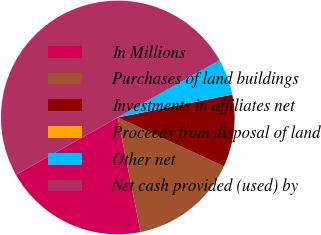Convert chart. <chart><loc_0><loc_0><loc_500><loc_500><pie_chart><fcel>In Millions<fcel>Purchases of land buildings<fcel>Investments in affiliates net<fcel>Proceeds from disposal of land<fcel>Other net<fcel>Net cash provided (used) by<nl><fcel>20.0%<fcel>15.0%<fcel>10.0%<fcel>0.01%<fcel>5.01%<fcel>49.98%<nl></chart> 